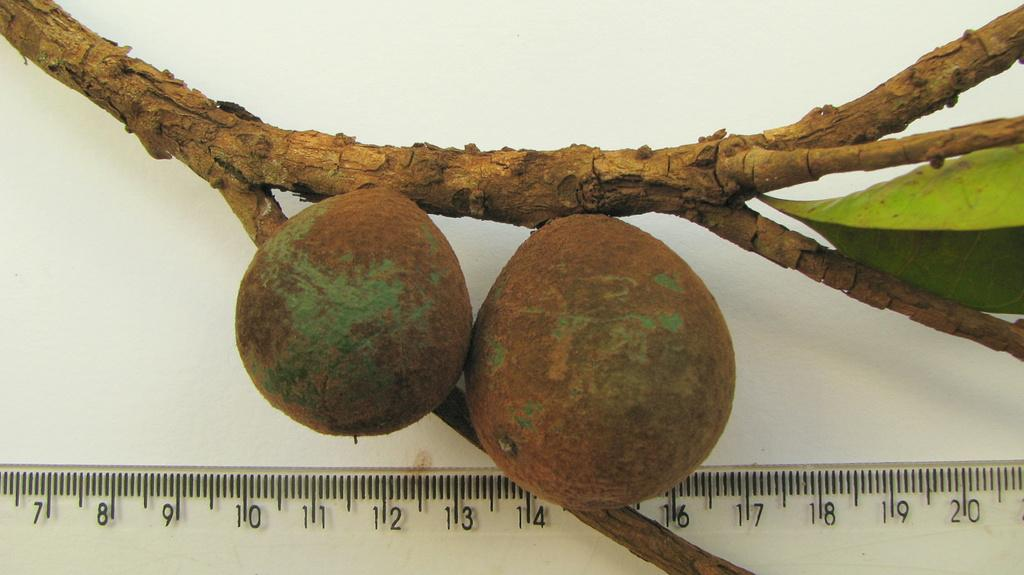<image>
Create a compact narrative representing the image presented. A branch is being measured against a ruler from numbers 7 to 20. 